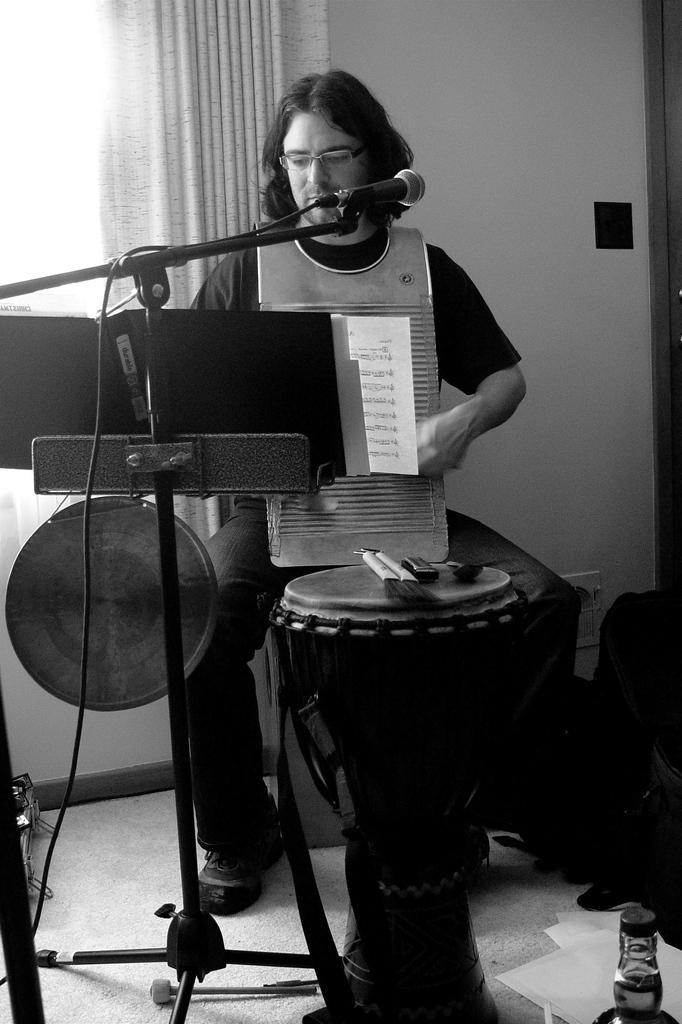Please provide a concise description of this image. In this image I see a man who is sitting and there is a mic and a book in front of him and I can also see there is a musical instrument and a bottle over here. In the background I can see the wall and the curtain. 